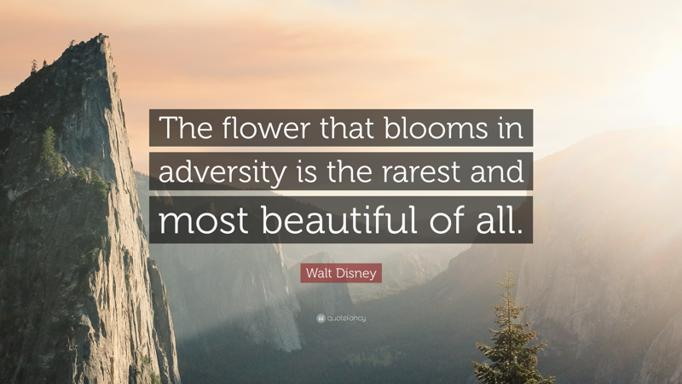What emotions does this combination of a profound quote with a breathtaking natural scene evoke in you? The combination of Walt Disney’s inspiring words with the sublime natural backdrop evokes a sense of awe and motivation. It reminds us of life's dual essence—its trials and beauties—and encourages a contemplative state where we appreciate the journey as much as the destination. This scene stirs a mix of inspiration, admiration, and deep reflection on one’s resilience and the beauty that trials can unveil. 